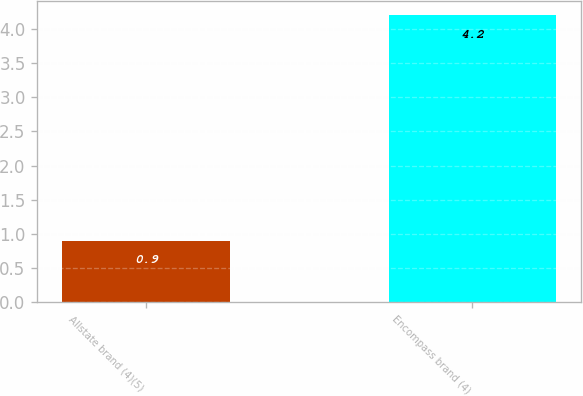Convert chart. <chart><loc_0><loc_0><loc_500><loc_500><bar_chart><fcel>Allstate brand (4)(5)<fcel>Encompass brand (4)<nl><fcel>0.9<fcel>4.2<nl></chart> 